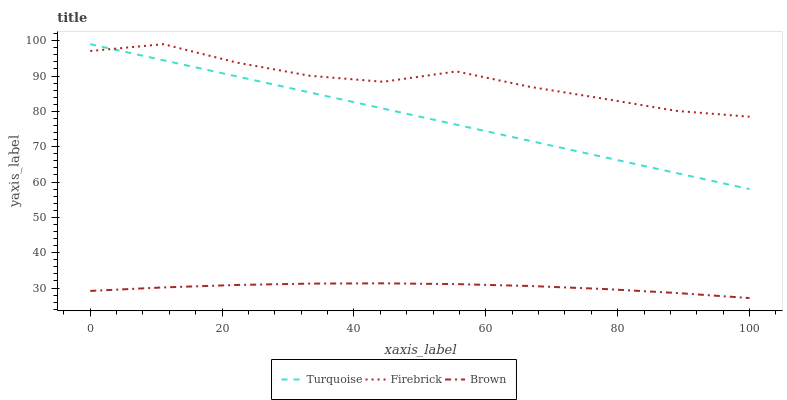Does Brown have the minimum area under the curve?
Answer yes or no. Yes. Does Firebrick have the maximum area under the curve?
Answer yes or no. Yes. Does Turquoise have the minimum area under the curve?
Answer yes or no. No. Does Turquoise have the maximum area under the curve?
Answer yes or no. No. Is Turquoise the smoothest?
Answer yes or no. Yes. Is Firebrick the roughest?
Answer yes or no. Yes. Is Firebrick the smoothest?
Answer yes or no. No. Is Turquoise the roughest?
Answer yes or no. No. Does Brown have the lowest value?
Answer yes or no. Yes. Does Turquoise have the lowest value?
Answer yes or no. No. Does Firebrick have the highest value?
Answer yes or no. Yes. Is Brown less than Turquoise?
Answer yes or no. Yes. Is Turquoise greater than Brown?
Answer yes or no. Yes. Does Turquoise intersect Firebrick?
Answer yes or no. Yes. Is Turquoise less than Firebrick?
Answer yes or no. No. Is Turquoise greater than Firebrick?
Answer yes or no. No. Does Brown intersect Turquoise?
Answer yes or no. No. 